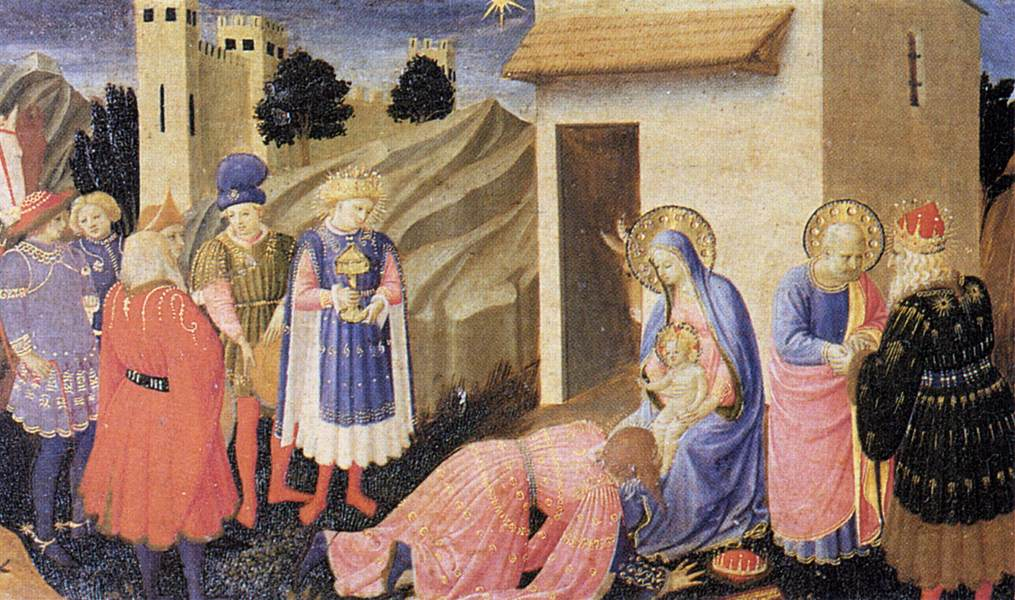What's happening in the scene? The image is a compelling representation of the Adoration of the Magi, a traditional Christian scene often depicted in medieval art. In this Gothic-style artwork, three Magi, or Wise Men, dressed in opulent robes of blue, red, and gold, are presenting gifts to the Virgin Mary and the infant Jesus. The Virgin Mary, depicted in a serene and radiant blue robe, looks at the infant Jesus with a gentle expression while he sits on her lap. Surrounding them are various figures, including those in colorful attire who have come to witness this significant event. The background features an intricately detailed castle and a church, adding a sense of depth and context to the scene. Above the group, a bright star shines, symbolizing the Star of Bethlehem that guided the Magi. The artist's use of vibrant colors and detailed composition highlights the significance of the event and reflects the religious fervor of the Gothic period. 